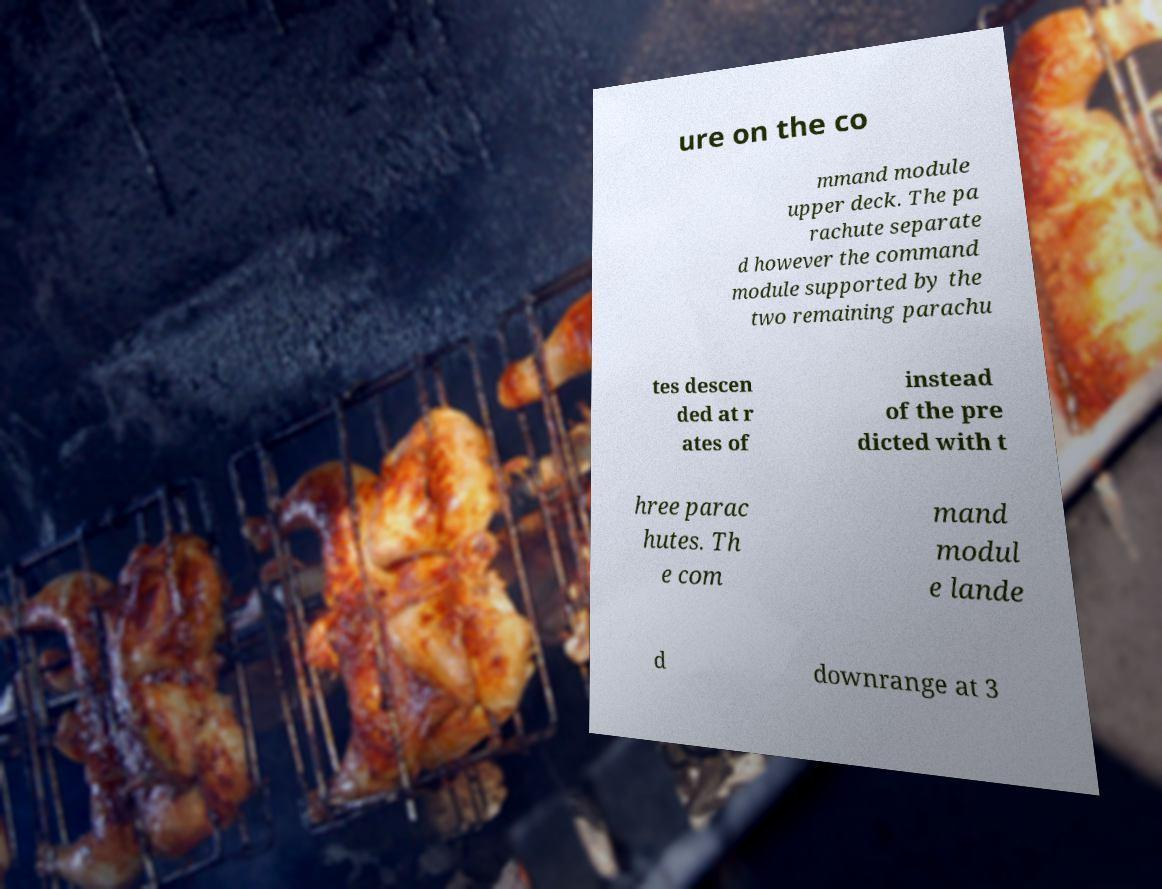What messages or text are displayed in this image? I need them in a readable, typed format. ure on the co mmand module upper deck. The pa rachute separate d however the command module supported by the two remaining parachu tes descen ded at r ates of instead of the pre dicted with t hree parac hutes. Th e com mand modul e lande d downrange at 3 